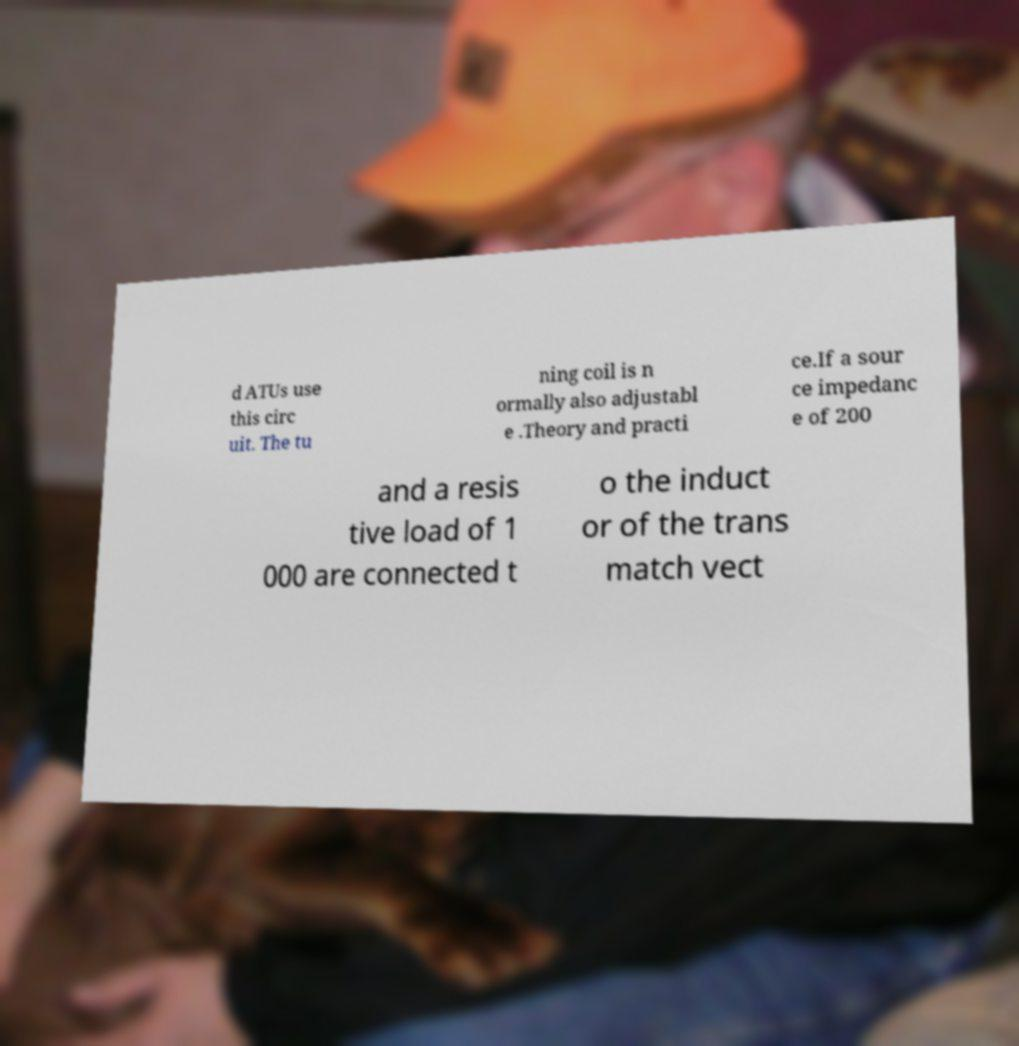Please identify and transcribe the text found in this image. d ATUs use this circ uit. The tu ning coil is n ormally also adjustabl e .Theory and practi ce.If a sour ce impedanc e of 200 and a resis tive load of 1 000 are connected t o the induct or of the trans match vect 